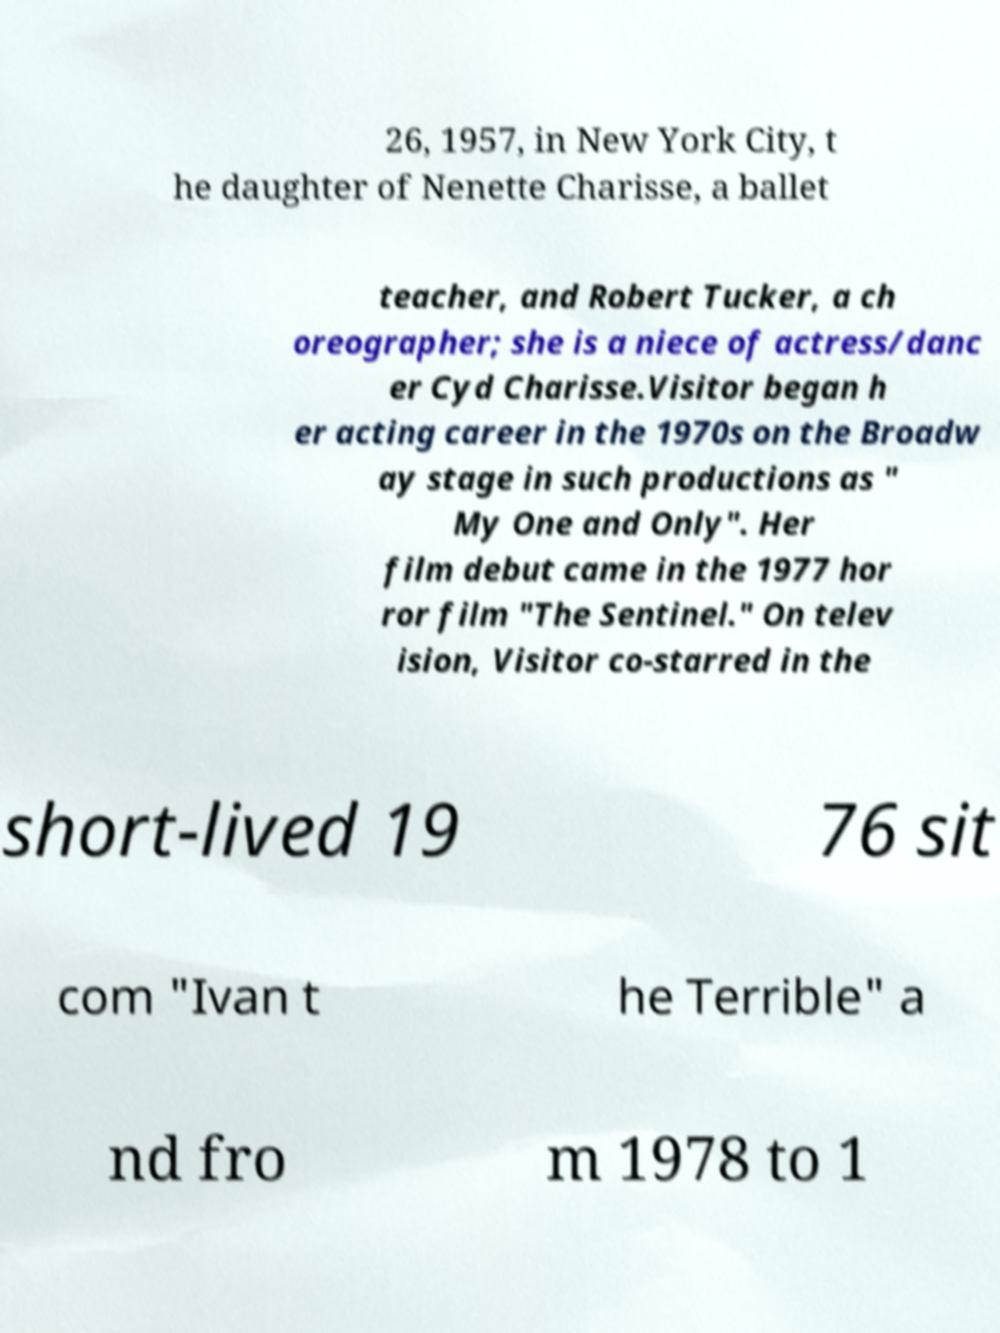Can you read and provide the text displayed in the image?This photo seems to have some interesting text. Can you extract and type it out for me? 26, 1957, in New York City, t he daughter of Nenette Charisse, a ballet teacher, and Robert Tucker, a ch oreographer; she is a niece of actress/danc er Cyd Charisse.Visitor began h er acting career in the 1970s on the Broadw ay stage in such productions as " My One and Only". Her film debut came in the 1977 hor ror film "The Sentinel." On telev ision, Visitor co-starred in the short-lived 19 76 sit com "Ivan t he Terrible" a nd fro m 1978 to 1 